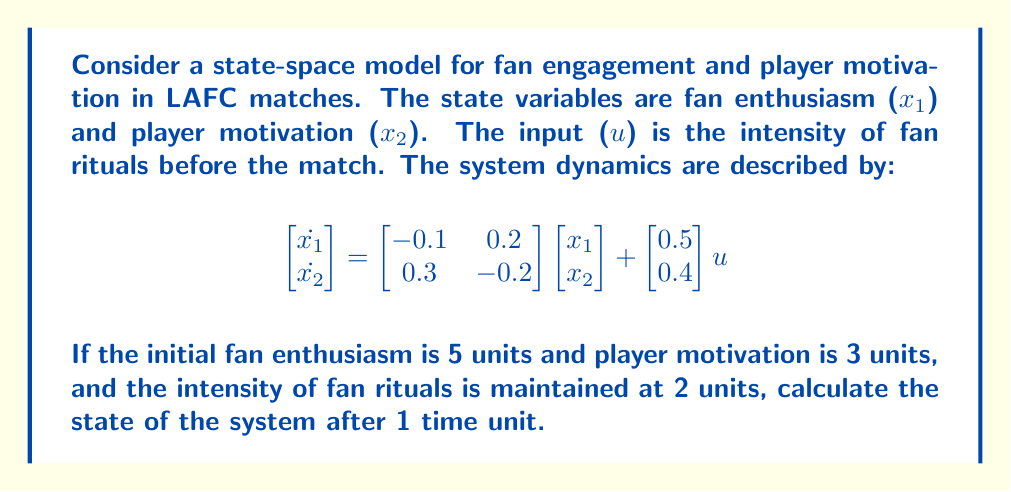Can you answer this question? To solve this problem, we need to use the state-space solution for a linear time-invariant system:

$$x(t) = e^{At}x(0) + \int_0^t e^{A(t-\tau)}Bu(\tau)d\tau$$

Where:
- $A = \begin{bmatrix} -0.1 & 0.2 \\ 0.3 & -0.2 \end{bmatrix}$
- $B = \begin{bmatrix} 0.5 \\ 0.4 \end{bmatrix}$
- $x(0) = \begin{bmatrix} 5 \\ 3 \end{bmatrix}$
- $u(t) = 2$ (constant input)

Steps:
1) Calculate $e^{At}$ using eigenvalue decomposition:
   Eigenvalues: $\lambda_1 \approx 0.1583$, $\lambda_2 \approx -0.4583$
   Eigenvectors: $v_1 \approx \begin{bmatrix} 0.7071 \\ 0.7071 \end{bmatrix}$, $v_2 \approx \begin{bmatrix} -0.5774 \\ 0.8165 \end{bmatrix}$
   
   $$e^{At} \approx \begin{bmatrix} 0.9231 & 0.1538 \\ 0.2308 & 0.8462 \end{bmatrix}$$

2) Calculate $A^{-1}B$:
   $$A^{-1}B = \begin{bmatrix} 3.3333 \\ 5.0000 \end{bmatrix}$$

3) Apply the solution formula:
   $$x(1) = e^{A(1)}x(0) + (e^{A(1)} - I)A^{-1}Bu$$

4) Compute the result:
   $$x(1) \approx \begin{bmatrix} 0.9231 & 0.1538 \\ 0.2308 & 0.8462 \end{bmatrix} \begin{bmatrix} 5 \\ 3 \end{bmatrix} + \begin{bmatrix} 0.3077 & 0.1538 \\ 0.2308 & 0.1538 \end{bmatrix} \begin{bmatrix} 3.3333 \\ 5.0000 \end{bmatrix} 2$$
Answer: $$x(1) \approx \begin{bmatrix} 7.9231 \\ 6.3846 \end{bmatrix}$$

After 1 time unit, fan enthusiasm is approximately 7.9231 units and player motivation is approximately 6.3846 units. 